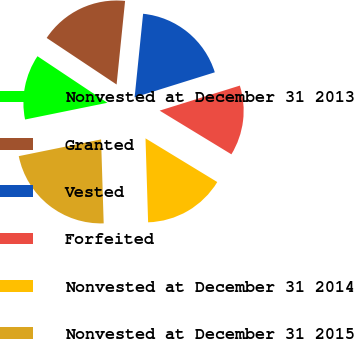Convert chart to OTSL. <chart><loc_0><loc_0><loc_500><loc_500><pie_chart><fcel>Nonvested at December 31 2013<fcel>Granted<fcel>Vested<fcel>Forfeited<fcel>Nonvested at December 31 2014<fcel>Nonvested at December 31 2015<nl><fcel>12.54%<fcel>17.26%<fcel>18.57%<fcel>13.52%<fcel>15.8%<fcel>22.3%<nl></chart> 